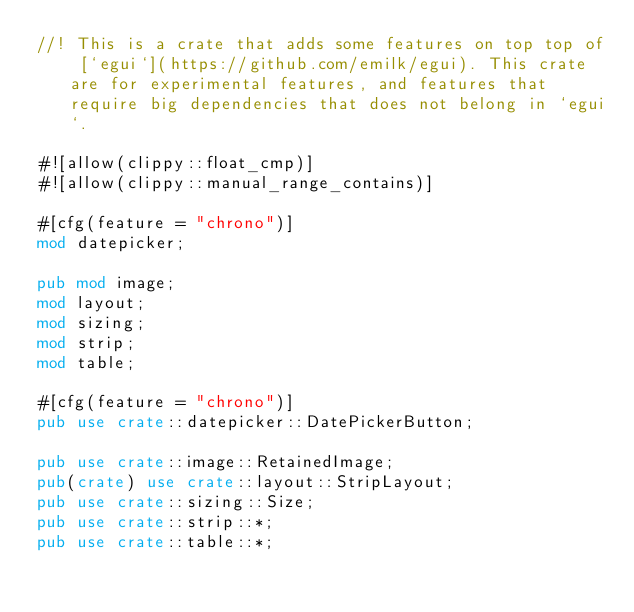Convert code to text. <code><loc_0><loc_0><loc_500><loc_500><_Rust_>//! This is a crate that adds some features on top top of [`egui`](https://github.com/emilk/egui). This crate are for experimental features, and features that require big dependencies that does not belong in `egui`.

#![allow(clippy::float_cmp)]
#![allow(clippy::manual_range_contains)]

#[cfg(feature = "chrono")]
mod datepicker;

pub mod image;
mod layout;
mod sizing;
mod strip;
mod table;

#[cfg(feature = "chrono")]
pub use crate::datepicker::DatePickerButton;

pub use crate::image::RetainedImage;
pub(crate) use crate::layout::StripLayout;
pub use crate::sizing::Size;
pub use crate::strip::*;
pub use crate::table::*;
</code> 